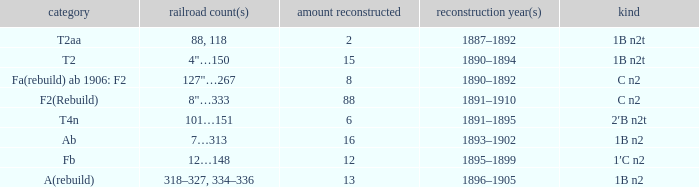What is the type if quantity rebuilt is more than 2 and the railway number is 4"…150? 1B n2t. 